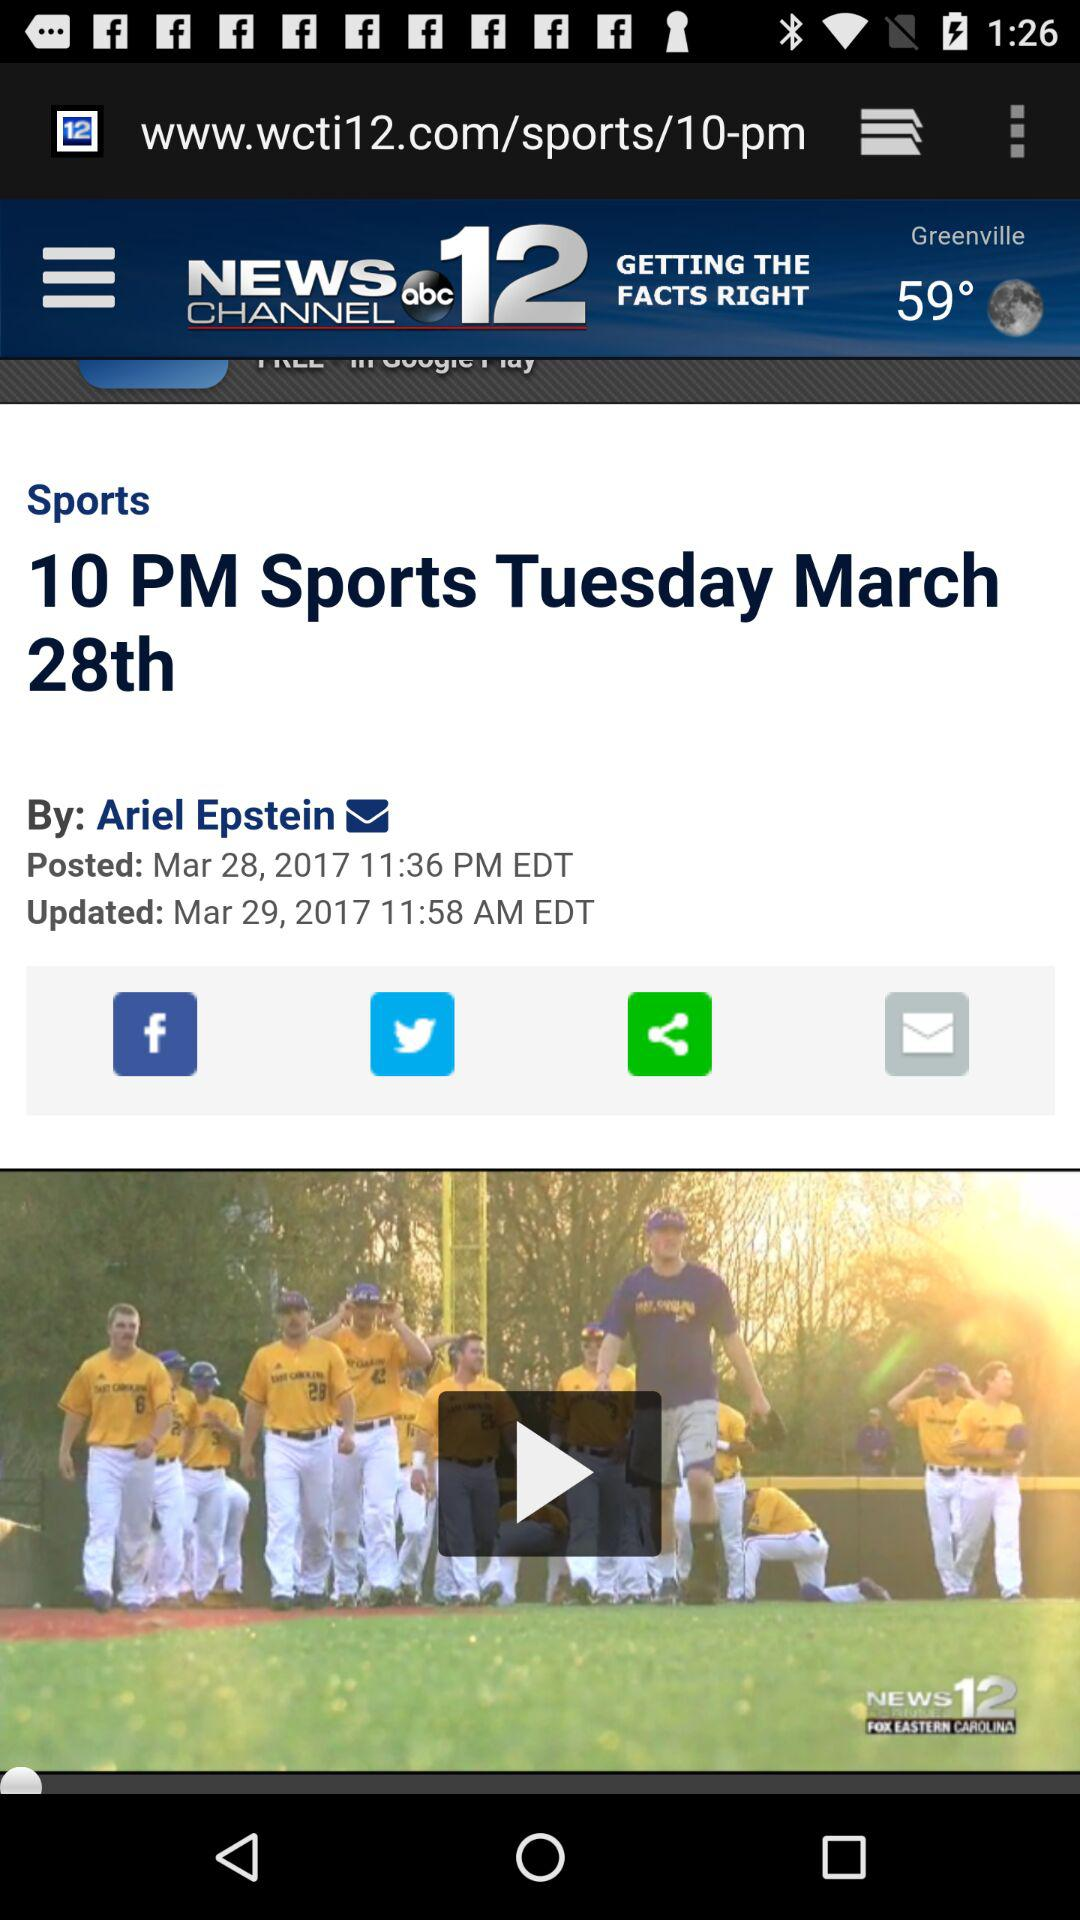Through which application can it be shared? It can be shared through "Facebook" and "Twitter". 